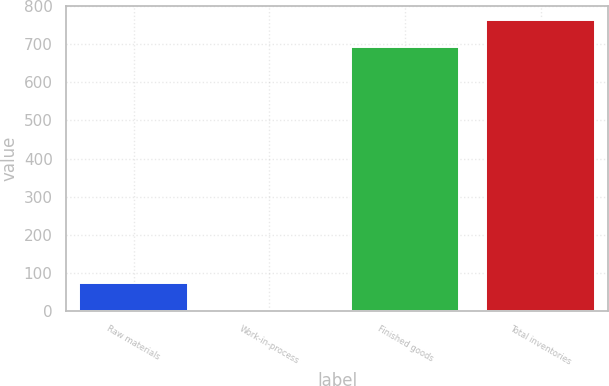Convert chart to OTSL. <chart><loc_0><loc_0><loc_500><loc_500><bar_chart><fcel>Raw materials<fcel>Work-in-process<fcel>Finished goods<fcel>Total inventories<nl><fcel>71.83<fcel>1.8<fcel>692.8<fcel>762.83<nl></chart> 